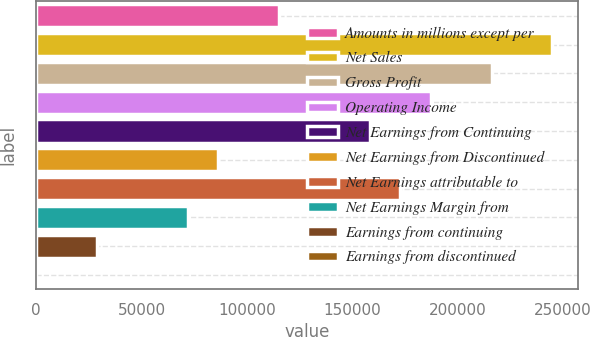<chart> <loc_0><loc_0><loc_500><loc_500><bar_chart><fcel>Amounts in millions except per<fcel>Net Sales<fcel>Gross Profit<fcel>Operating Income<fcel>Net Earnings from Continuing<fcel>Net Earnings from Discontinued<fcel>Net Earnings attributable to<fcel>Net Earnings Margin from<fcel>Earnings from continuing<fcel>Earnings from discontinued<nl><fcel>115194<fcel>244786<fcel>215988<fcel>187190<fcel>158391<fcel>86395.3<fcel>172790<fcel>71996.1<fcel>28798.6<fcel>0.3<nl></chart> 